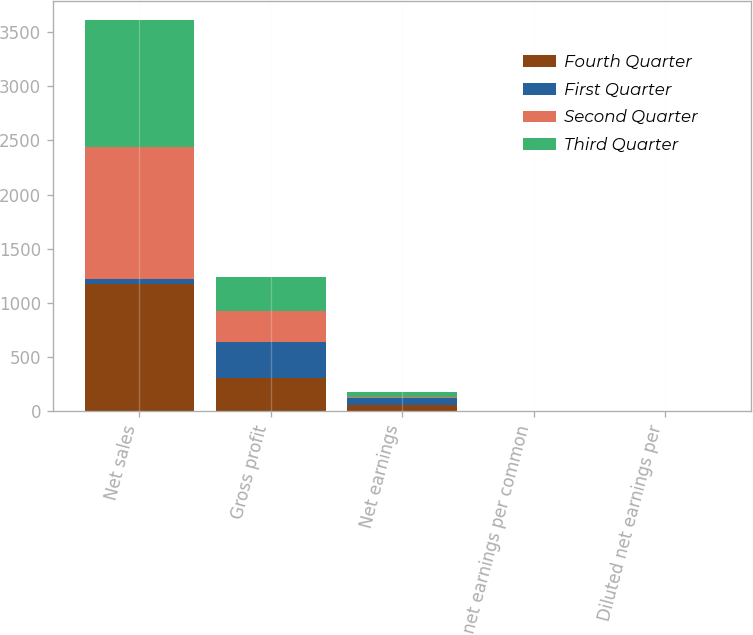<chart> <loc_0><loc_0><loc_500><loc_500><stacked_bar_chart><ecel><fcel>Net sales<fcel>Gross profit<fcel>Net earnings<fcel>Basic net earnings per common<fcel>Diluted net earnings per<nl><fcel>Fourth Quarter<fcel>1177.4<fcel>305.1<fcel>60.8<fcel>0.38<fcel>0.33<nl><fcel>First Quarter<fcel>47.3<fcel>330.2<fcel>62.6<fcel>0.39<fcel>0.34<nl><fcel>Second Quarter<fcel>1219<fcel>293.7<fcel>9.2<fcel>0.06<fcel>0.05<nl><fcel>Third Quarter<fcel>1168.3<fcel>307.6<fcel>47.3<fcel>0.3<fcel>0.26<nl></chart> 